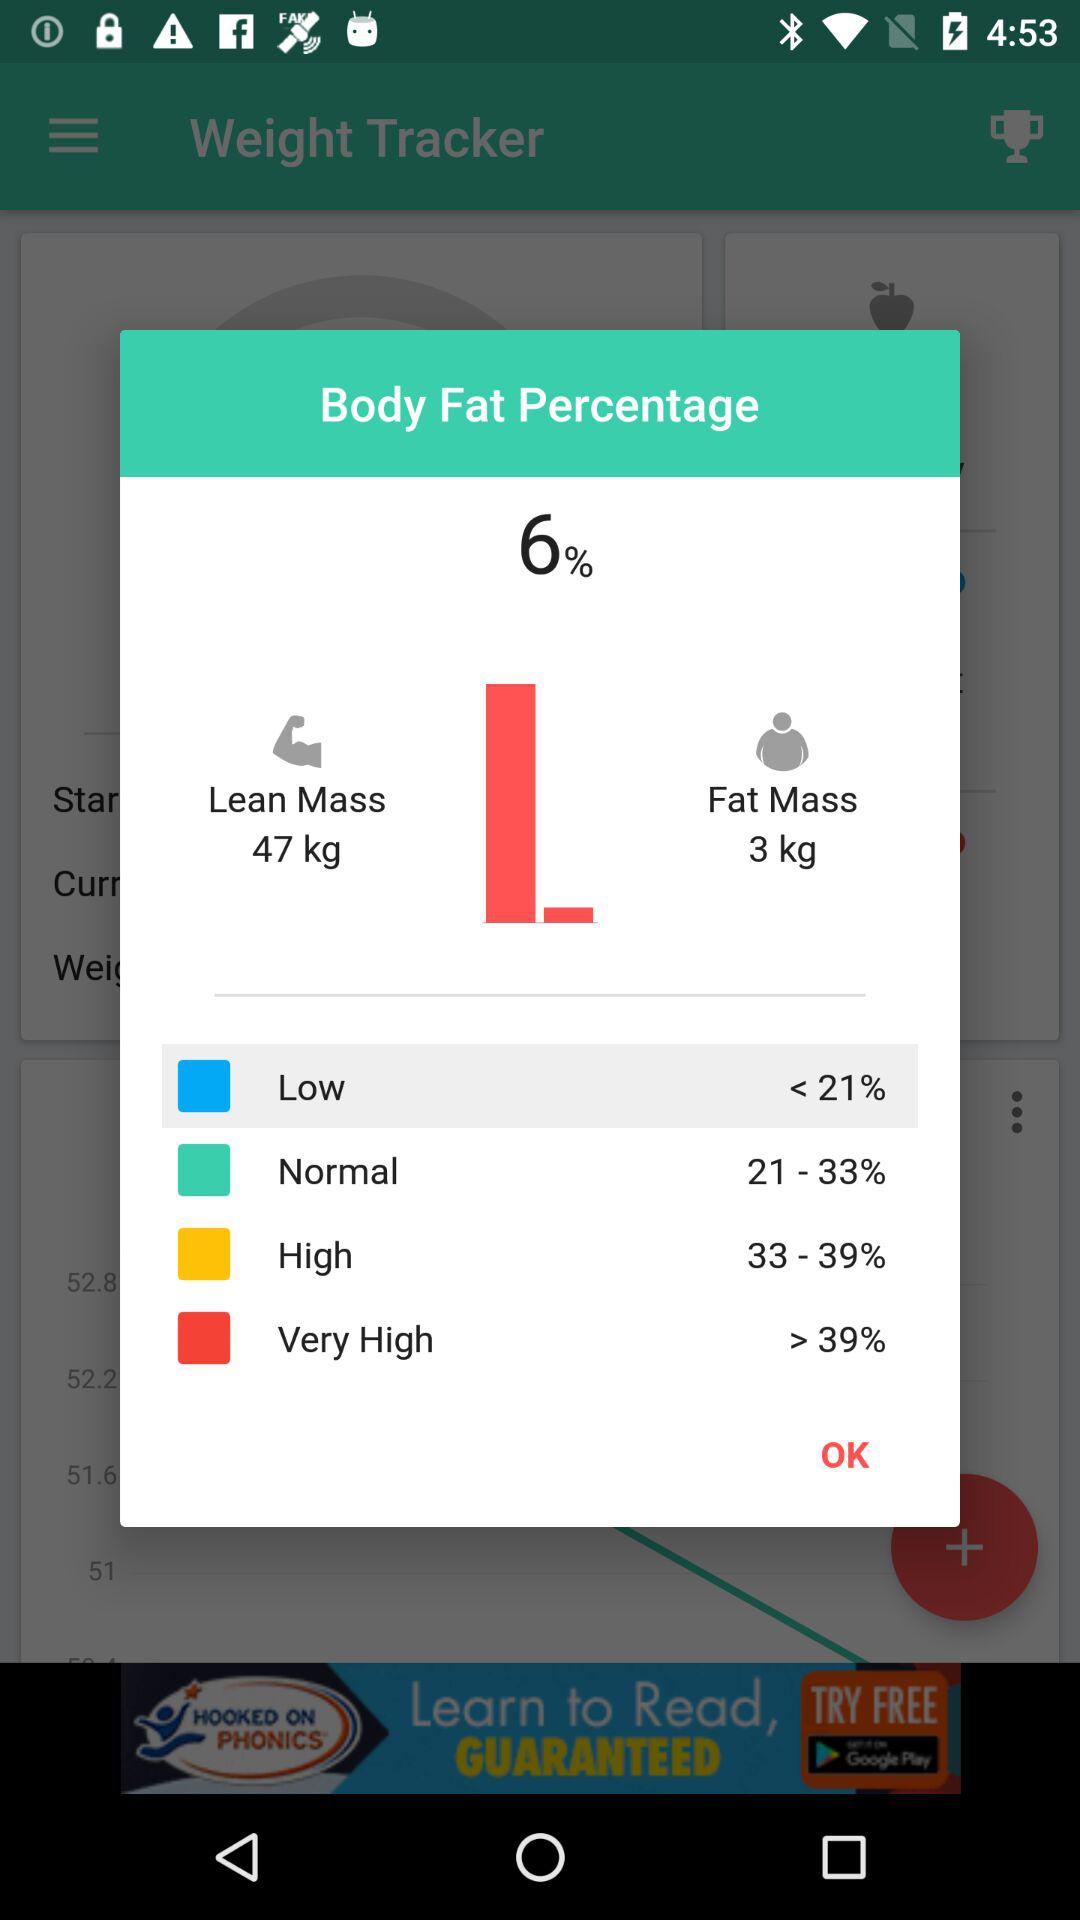How much is the fat mass? The fat mass is 3 kg. 